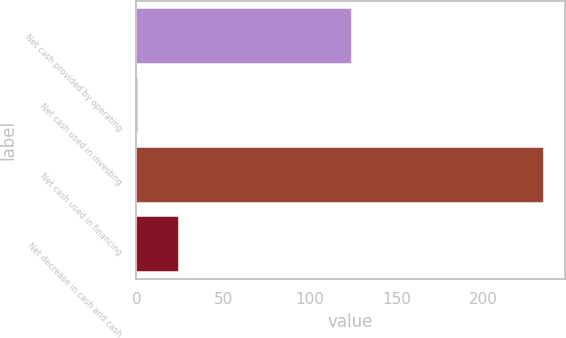Convert chart. <chart><loc_0><loc_0><loc_500><loc_500><bar_chart><fcel>Net cash provided by operating<fcel>Net cash used in investing<fcel>Net cash used in financing<fcel>Net decrease in cash and cash<nl><fcel>124<fcel>1<fcel>235<fcel>24.4<nl></chart> 